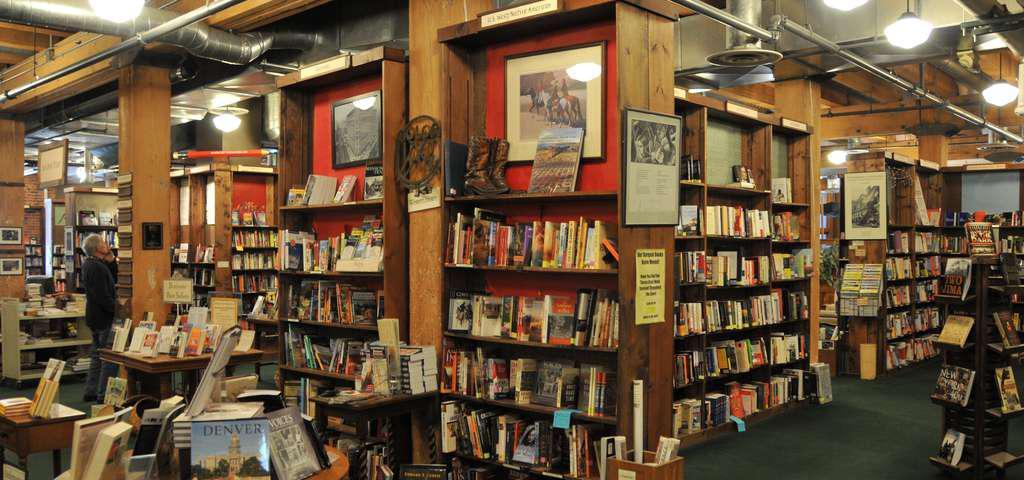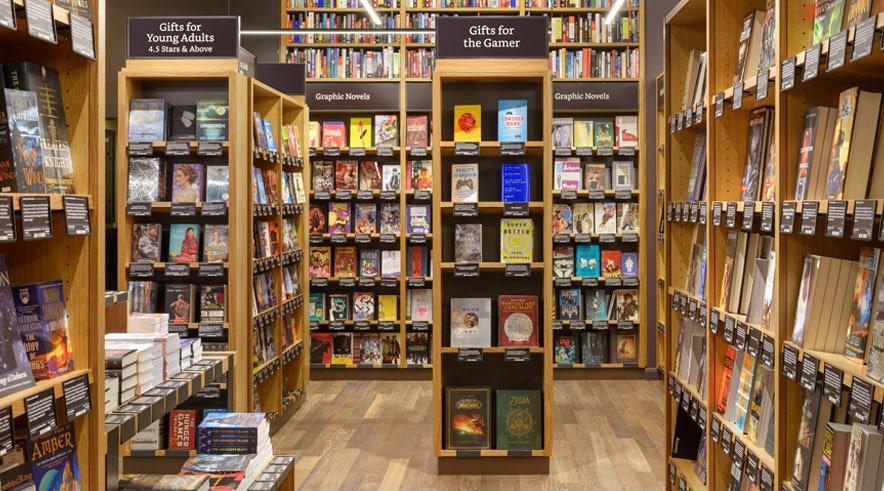The first image is the image on the left, the second image is the image on the right. Analyze the images presented: Is the assertion "One image is straight down an uncluttered, carpeted aisle with books shelved on both sides." valid? Answer yes or no. No. 